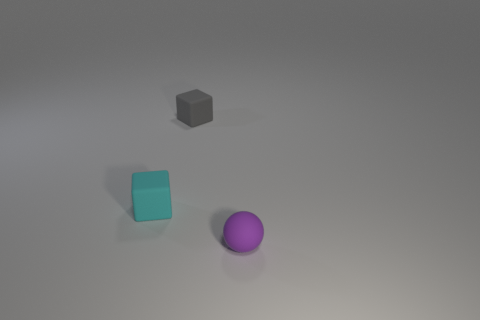Describe the lighting and shadows in the image. The lighting in the image appears to be coming from the upper left direction, casting soft shadows to the right of the objects, indicating a diffuse light source. 